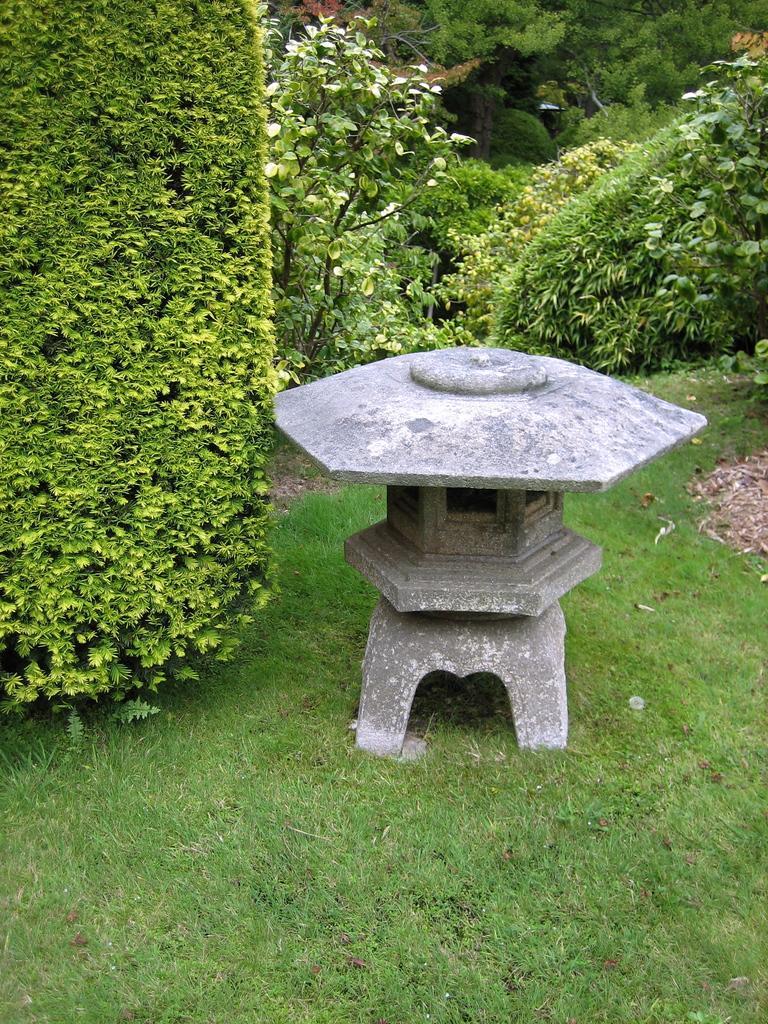Please provide a concise description of this image. In the foreground there is grass. In the middle there are trees, dry leaves and a stone object. In the background there are trees and plants. 